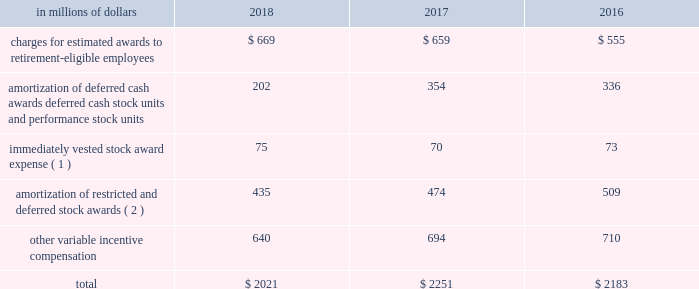Incentive compensation cost the table shows components of compensation expense , relating to certain of the incentive compensation programs described above : in a0millions a0of a0dollars 2018 2017 2016 charges for estimated awards to retirement-eligible employees $ 669 $ 659 $ 555 amortization of deferred cash awards , deferred cash stock units and performance stock units 202 354 336 immediately vested stock award expense ( 1 ) 75 70 73 amortization of restricted and deferred stock awards ( 2 ) 435 474 509 .
( 1 ) represents expense for immediately vested stock awards that generally were stock payments in lieu of cash compensation .
The expense is generally accrued as cash incentive compensation in the year prior to grant .
( 2 ) all periods include amortization expense for all unvested awards to non-retirement-eligible employees. .
What was the percentage change in the total incentive compensation from 2017 to 2018? 
Rationale: the total incentive compensation declined by 10.3% from 2017 to 2018
Computations: ((2021 - 2251) / 2251)
Answer: -0.10218. 